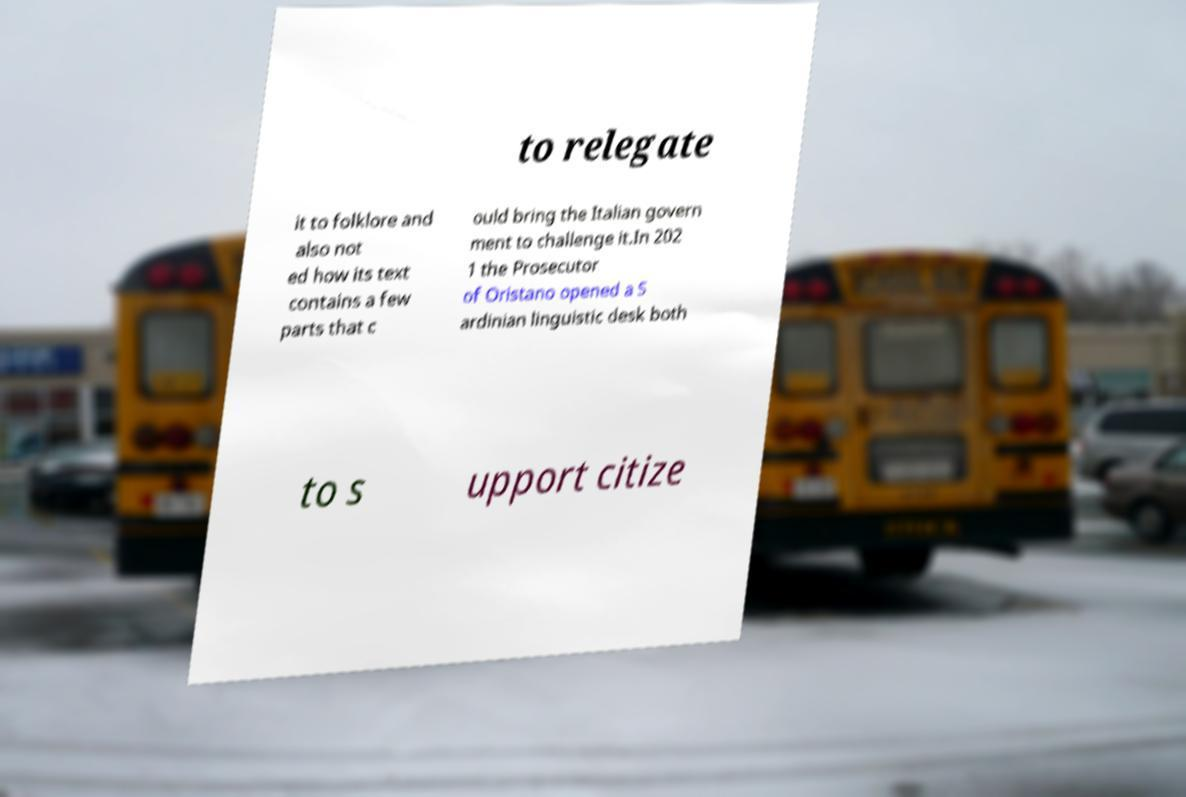For documentation purposes, I need the text within this image transcribed. Could you provide that? to relegate it to folklore and also not ed how its text contains a few parts that c ould bring the Italian govern ment to challenge it.In 202 1 the Prosecutor of Oristano opened a S ardinian linguistic desk both to s upport citize 